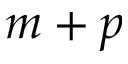Convert formula to latex. <formula><loc_0><loc_0><loc_500><loc_500>m + p</formula> 